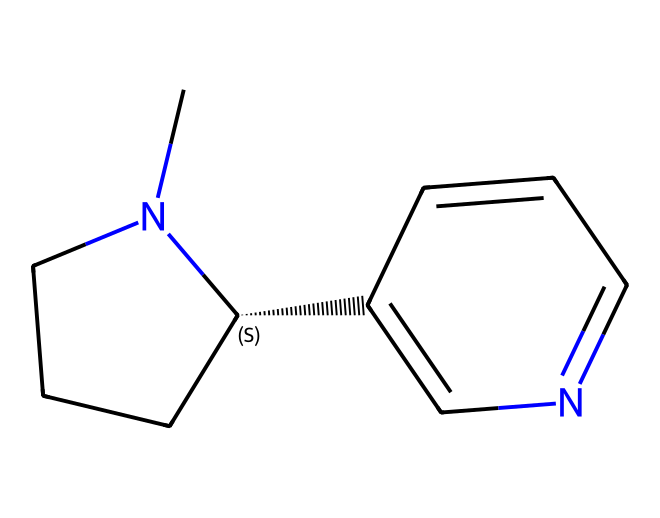How many carbon atoms are present in this chemical structure? By examining the structure represented by the SMILES notation, we can count the carbon (C) atoms. The SMILES shows multiple 'C' characters, indicating the presence of several carbon atoms. In total, there are 10 carbon atoms in the structure.
Answer: 10 What is the main nitrogen-containing group in this compound? Looking at the structure, we can see that there are nitrogen (N) atoms present. In alkaloids, these nitrogen groups often form rings or are part of cycles. The primary nitrogen is part of the piperidine and pyridine rings in nicotine, which are characteristic features of this alkaloid.
Answer: piperidine and pyridine How many rings are present in the chemical structure? Analyzing the structure, we note that there are two distinct cyclic parts. One is the piperidine ring, and the other is the pyridine ring. Both contribute to the overall cyclic structure of nicotine.
Answer: 2 What functional groups are indicated by the presence of nitrogen atoms? In the chemical structure represented, nitrogen atoms contribute to the basic alkaloid structure. The nitrogen atoms suggest the molecule functions as a base due to their lone pairs, which can accept protons, fitting the behavior of alkaloids like nicotine.
Answer: amines Is this alkaloid known to have any psychoactive effects? Considering the well-known properties of nicotine, which is an alkaloid derived from tobacco, it is widely recognized for its psychoactive effects, particularly its stimulant properties on the central nervous system.
Answer: yes 